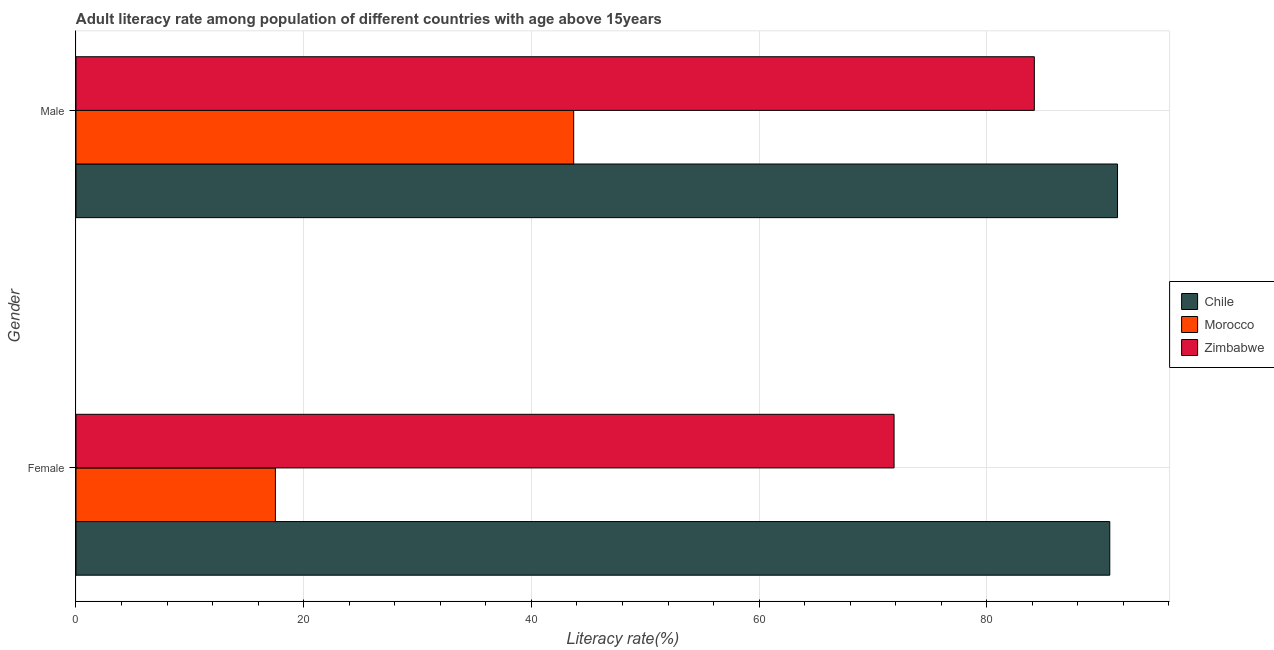How many different coloured bars are there?
Your answer should be compact. 3. Are the number of bars per tick equal to the number of legend labels?
Keep it short and to the point. Yes. Are the number of bars on each tick of the Y-axis equal?
Provide a short and direct response. Yes. How many bars are there on the 2nd tick from the top?
Your answer should be compact. 3. What is the male adult literacy rate in Morocco?
Give a very brief answer. 43.71. Across all countries, what is the maximum male adult literacy rate?
Your answer should be very brief. 91.48. Across all countries, what is the minimum female adult literacy rate?
Make the answer very short. 17.51. In which country was the female adult literacy rate minimum?
Offer a terse response. Morocco. What is the total male adult literacy rate in the graph?
Your response must be concise. 219.37. What is the difference between the female adult literacy rate in Chile and that in Morocco?
Offer a very short reply. 73.29. What is the difference between the female adult literacy rate in Morocco and the male adult literacy rate in Zimbabwe?
Keep it short and to the point. -66.66. What is the average female adult literacy rate per country?
Make the answer very short. 60.06. What is the difference between the male adult literacy rate and female adult literacy rate in Morocco?
Keep it short and to the point. 26.2. In how many countries, is the female adult literacy rate greater than 40 %?
Ensure brevity in your answer.  2. What is the ratio of the male adult literacy rate in Zimbabwe to that in Chile?
Your response must be concise. 0.92. In how many countries, is the female adult literacy rate greater than the average female adult literacy rate taken over all countries?
Offer a terse response. 2. What does the 2nd bar from the top in Female represents?
Provide a succinct answer. Morocco. What does the 3rd bar from the bottom in Female represents?
Your response must be concise. Zimbabwe. Are all the bars in the graph horizontal?
Provide a short and direct response. Yes. Are the values on the major ticks of X-axis written in scientific E-notation?
Ensure brevity in your answer.  No. Does the graph contain any zero values?
Ensure brevity in your answer.  No. How many legend labels are there?
Your answer should be compact. 3. How are the legend labels stacked?
Offer a terse response. Vertical. What is the title of the graph?
Keep it short and to the point. Adult literacy rate among population of different countries with age above 15years. What is the label or title of the X-axis?
Give a very brief answer. Literacy rate(%). What is the label or title of the Y-axis?
Give a very brief answer. Gender. What is the Literacy rate(%) of Chile in Female?
Your answer should be very brief. 90.8. What is the Literacy rate(%) in Morocco in Female?
Your answer should be very brief. 17.51. What is the Literacy rate(%) in Zimbabwe in Female?
Your answer should be very brief. 71.85. What is the Literacy rate(%) of Chile in Male?
Your answer should be very brief. 91.48. What is the Literacy rate(%) of Morocco in Male?
Keep it short and to the point. 43.71. What is the Literacy rate(%) in Zimbabwe in Male?
Give a very brief answer. 84.17. Across all Gender, what is the maximum Literacy rate(%) of Chile?
Your answer should be very brief. 91.48. Across all Gender, what is the maximum Literacy rate(%) of Morocco?
Your answer should be very brief. 43.71. Across all Gender, what is the maximum Literacy rate(%) in Zimbabwe?
Provide a succinct answer. 84.17. Across all Gender, what is the minimum Literacy rate(%) of Chile?
Keep it short and to the point. 90.8. Across all Gender, what is the minimum Literacy rate(%) of Morocco?
Offer a terse response. 17.51. Across all Gender, what is the minimum Literacy rate(%) in Zimbabwe?
Your response must be concise. 71.85. What is the total Literacy rate(%) of Chile in the graph?
Your response must be concise. 182.28. What is the total Literacy rate(%) in Morocco in the graph?
Your answer should be compact. 61.23. What is the total Literacy rate(%) of Zimbabwe in the graph?
Offer a terse response. 156.03. What is the difference between the Literacy rate(%) in Chile in Female and that in Male?
Your response must be concise. -0.68. What is the difference between the Literacy rate(%) of Morocco in Female and that in Male?
Provide a succinct answer. -26.2. What is the difference between the Literacy rate(%) of Zimbabwe in Female and that in Male?
Provide a short and direct response. -12.32. What is the difference between the Literacy rate(%) in Chile in Female and the Literacy rate(%) in Morocco in Male?
Provide a short and direct response. 47.09. What is the difference between the Literacy rate(%) of Chile in Female and the Literacy rate(%) of Zimbabwe in Male?
Provide a succinct answer. 6.63. What is the difference between the Literacy rate(%) of Morocco in Female and the Literacy rate(%) of Zimbabwe in Male?
Provide a succinct answer. -66.66. What is the average Literacy rate(%) of Chile per Gender?
Give a very brief answer. 91.14. What is the average Literacy rate(%) of Morocco per Gender?
Your answer should be very brief. 30.61. What is the average Literacy rate(%) in Zimbabwe per Gender?
Your response must be concise. 78.01. What is the difference between the Literacy rate(%) in Chile and Literacy rate(%) in Morocco in Female?
Your response must be concise. 73.29. What is the difference between the Literacy rate(%) of Chile and Literacy rate(%) of Zimbabwe in Female?
Ensure brevity in your answer.  18.95. What is the difference between the Literacy rate(%) of Morocco and Literacy rate(%) of Zimbabwe in Female?
Make the answer very short. -54.34. What is the difference between the Literacy rate(%) of Chile and Literacy rate(%) of Morocco in Male?
Offer a terse response. 47.77. What is the difference between the Literacy rate(%) in Chile and Literacy rate(%) in Zimbabwe in Male?
Ensure brevity in your answer.  7.31. What is the difference between the Literacy rate(%) of Morocco and Literacy rate(%) of Zimbabwe in Male?
Your answer should be compact. -40.46. What is the ratio of the Literacy rate(%) in Morocco in Female to that in Male?
Your answer should be very brief. 0.4. What is the ratio of the Literacy rate(%) of Zimbabwe in Female to that in Male?
Ensure brevity in your answer.  0.85. What is the difference between the highest and the second highest Literacy rate(%) in Chile?
Make the answer very short. 0.68. What is the difference between the highest and the second highest Literacy rate(%) of Morocco?
Your response must be concise. 26.2. What is the difference between the highest and the second highest Literacy rate(%) of Zimbabwe?
Offer a very short reply. 12.32. What is the difference between the highest and the lowest Literacy rate(%) of Chile?
Provide a succinct answer. 0.68. What is the difference between the highest and the lowest Literacy rate(%) of Morocco?
Your answer should be compact. 26.2. What is the difference between the highest and the lowest Literacy rate(%) in Zimbabwe?
Ensure brevity in your answer.  12.32. 